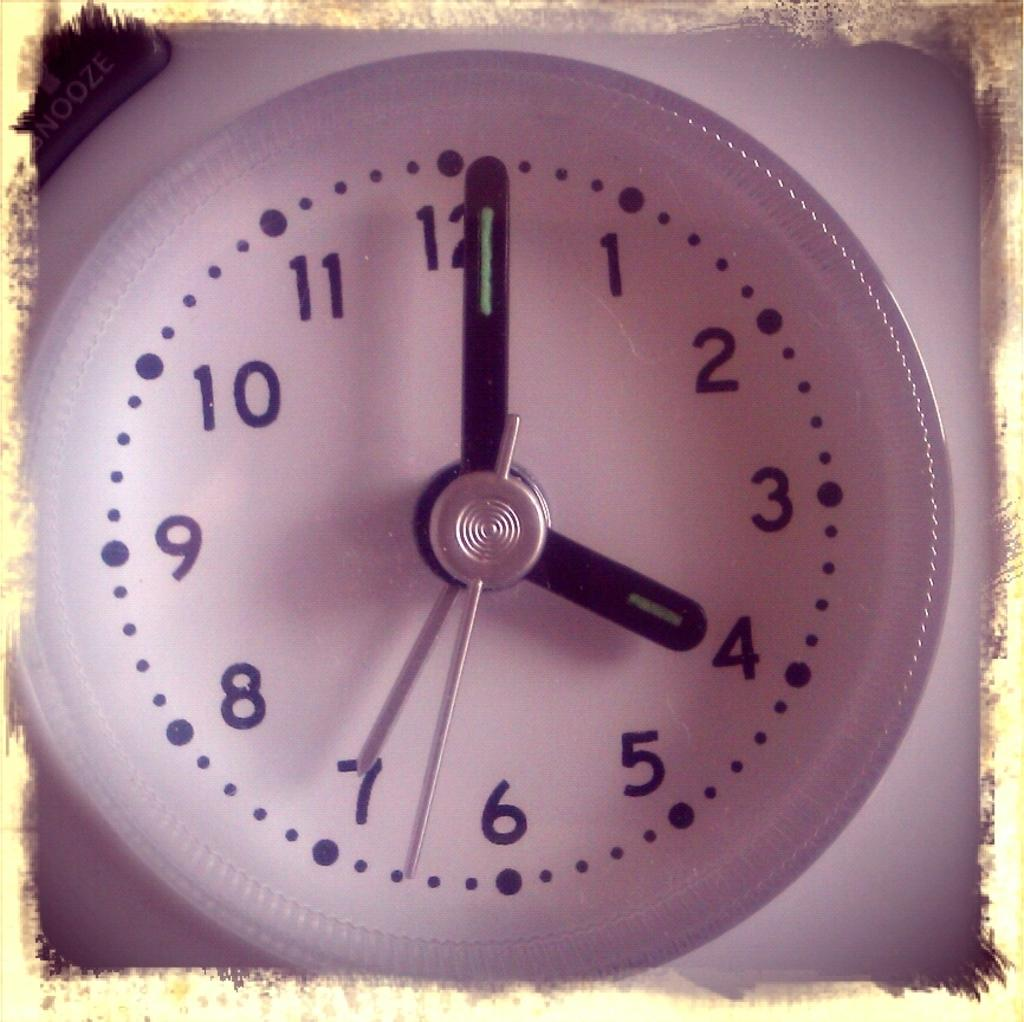<image>
Present a compact description of the photo's key features. The white clock shows that it is just past 4 o'clock. 